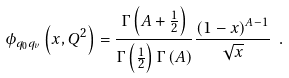<formula> <loc_0><loc_0><loc_500><loc_500>\phi _ { q _ { 0 } q _ { v } } \left ( x , Q ^ { 2 } \right ) = \frac { \Gamma \left ( A + \frac { 1 } { 2 } \right ) } { \Gamma \left ( \frac { 1 } { 2 } \right ) \Gamma \left ( A \right ) } \frac { \left ( 1 - x \right ) ^ { A - 1 } } { \sqrt { x } } \ .</formula> 